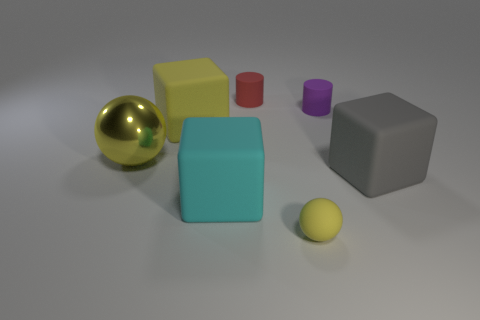Is there any other thing that has the same material as the large sphere?
Make the answer very short. No. There is a big rubber object right of the red cylinder; does it have the same shape as the big cyan rubber object?
Provide a short and direct response. Yes. The tiny rubber thing that is the same shape as the metal thing is what color?
Provide a short and direct response. Yellow. There is a sphere left of the small red rubber cylinder; what is its material?
Provide a succinct answer. Metal. Is the shape of the tiny yellow thing the same as the purple object?
Provide a succinct answer. No. What size is the cylinder in front of the tiny red rubber cylinder?
Your answer should be very brief. Small. How many objects are either big matte cubes that are left of the gray matte block or tiny matte things on the left side of the small purple rubber cylinder?
Offer a terse response. 4. Are there any other things of the same color as the matte sphere?
Your response must be concise. Yes. Are there the same number of large matte blocks that are behind the big cyan thing and large cyan blocks to the right of the yellow matte sphere?
Your answer should be very brief. No. Is the number of gray rubber things that are right of the big sphere greater than the number of small purple matte balls?
Your answer should be very brief. Yes. 